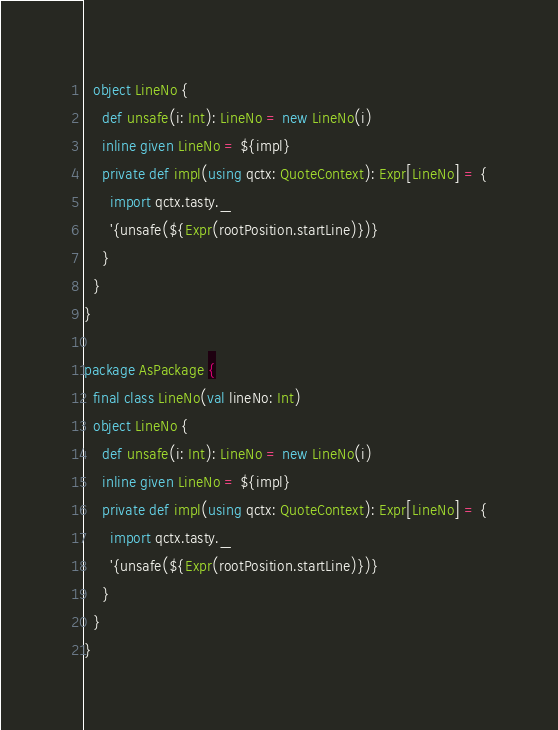Convert code to text. <code><loc_0><loc_0><loc_500><loc_500><_Scala_>  object LineNo {
    def unsafe(i: Int): LineNo = new LineNo(i)
    inline given LineNo = ${impl}
    private def impl(using qctx: QuoteContext): Expr[LineNo] = {
      import qctx.tasty._
      '{unsafe(${Expr(rootPosition.startLine)})}
    }
  }
}

package AsPackage {
  final class LineNo(val lineNo: Int)
  object LineNo {
    def unsafe(i: Int): LineNo = new LineNo(i)
    inline given LineNo = ${impl}
    private def impl(using qctx: QuoteContext): Expr[LineNo] = {
      import qctx.tasty._
      '{unsafe(${Expr(rootPosition.startLine)})}
    }
  }
}
</code> 